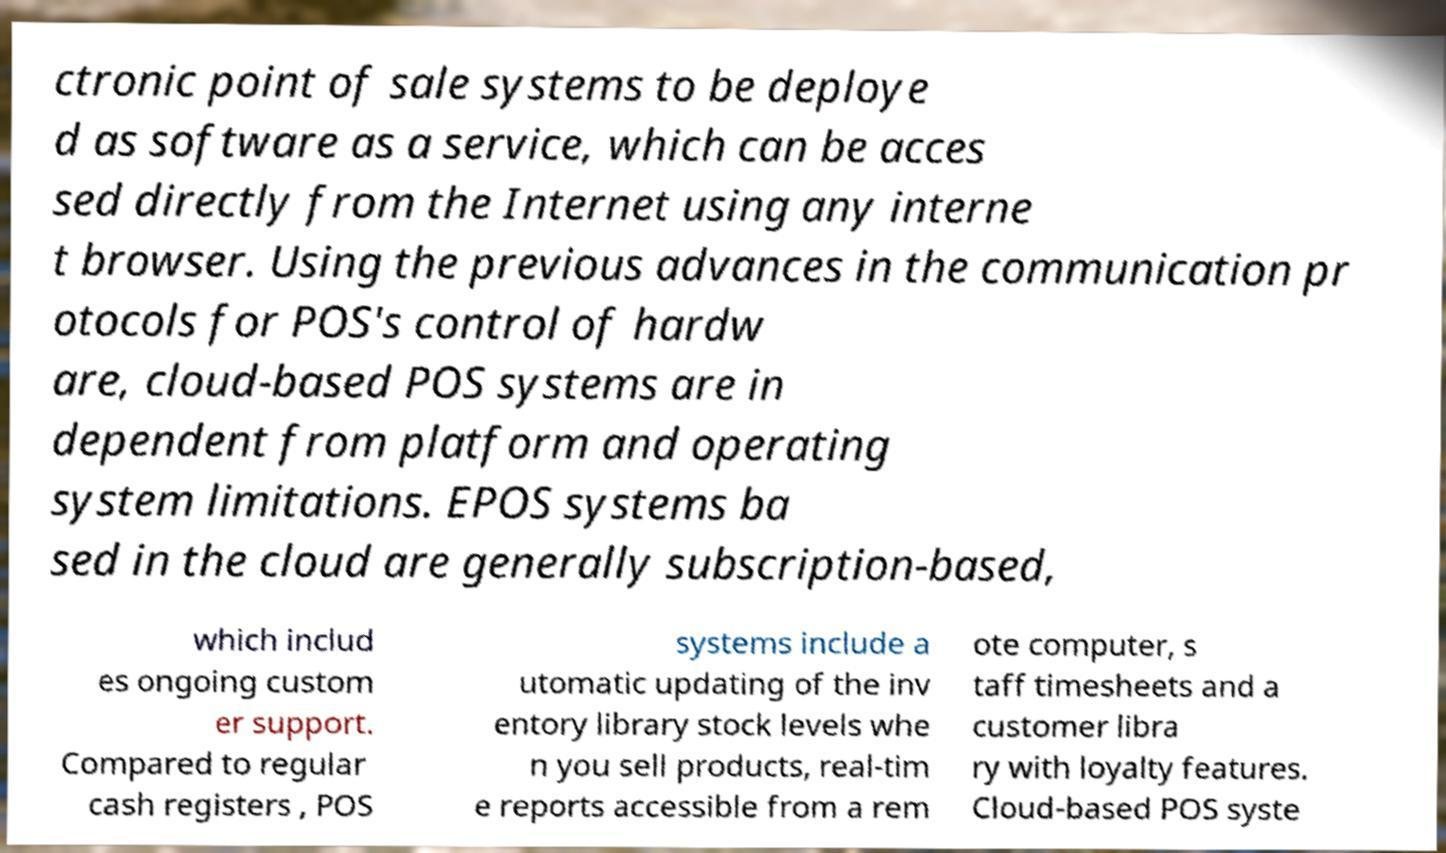There's text embedded in this image that I need extracted. Can you transcribe it verbatim? ctronic point of sale systems to be deploye d as software as a service, which can be acces sed directly from the Internet using any interne t browser. Using the previous advances in the communication pr otocols for POS's control of hardw are, cloud-based POS systems are in dependent from platform and operating system limitations. EPOS systems ba sed in the cloud are generally subscription-based, which includ es ongoing custom er support. Compared to regular cash registers , POS systems include a utomatic updating of the inv entory library stock levels whe n you sell products, real-tim e reports accessible from a rem ote computer, s taff timesheets and a customer libra ry with loyalty features. Cloud-based POS syste 